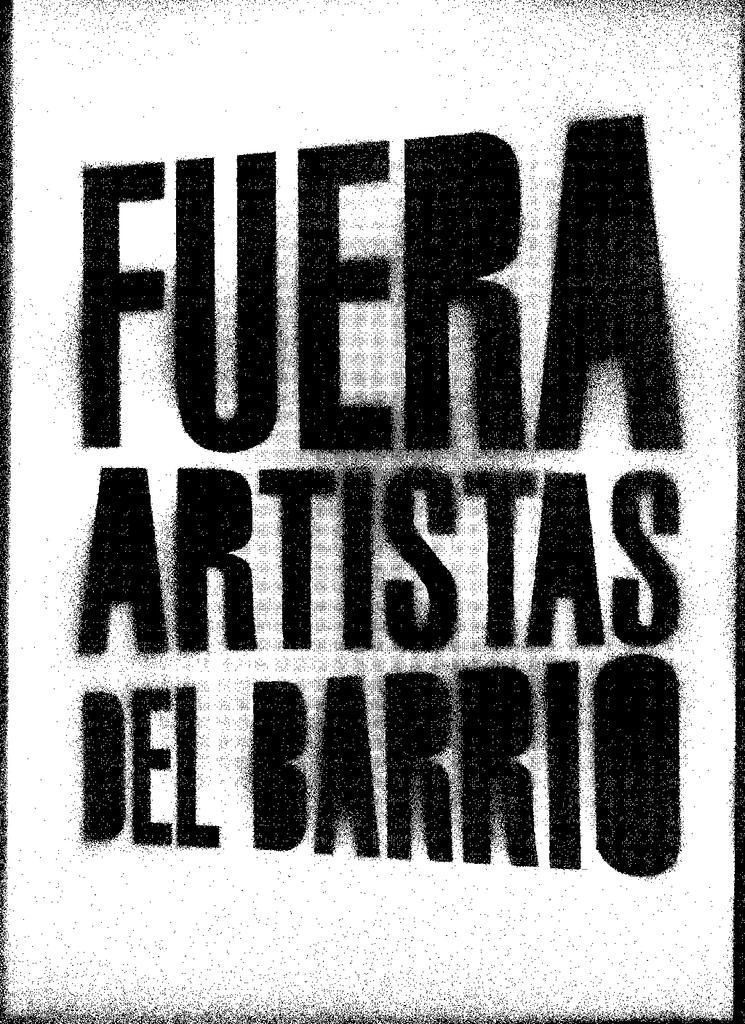<image>
Offer a succinct explanation of the picture presented. A spray painted poster reads Fuera Artistas Del Barrio. 